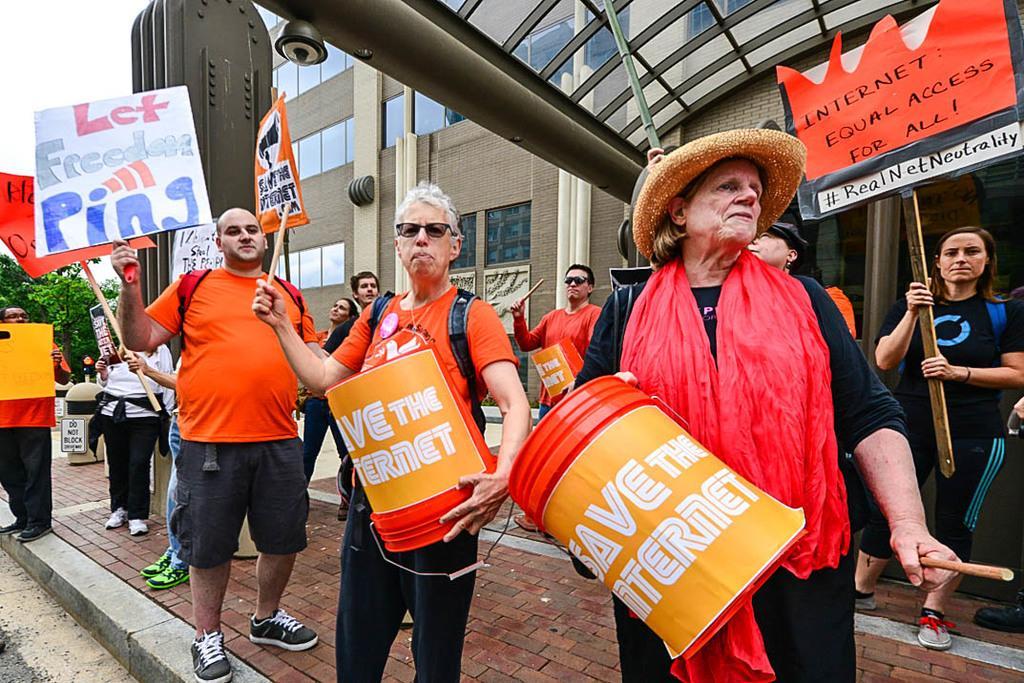How would you summarize this image in a sentence or two? In this picture we can see some people are playing drums and some people are holding boards, behind we can see buildings. 